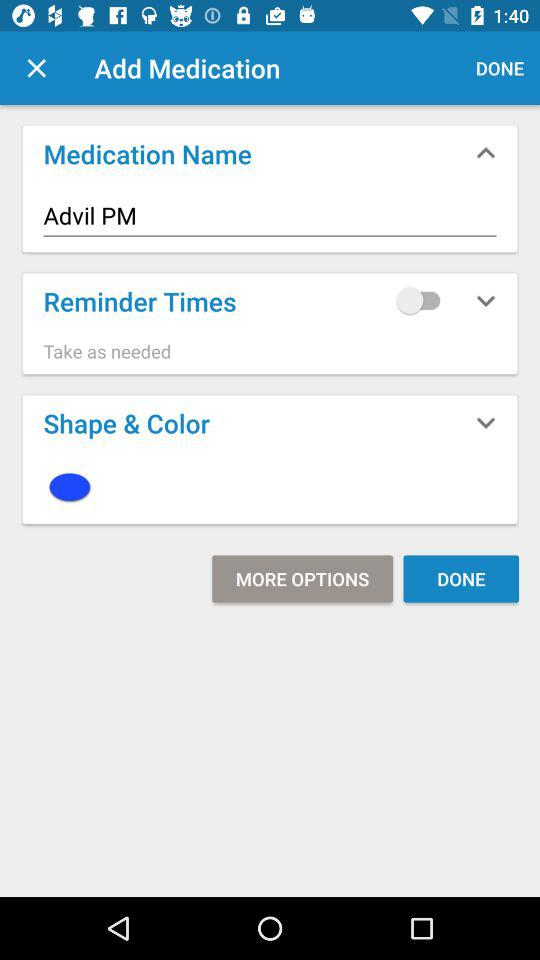What is the status of "Reminder Times"? The status is "off". 